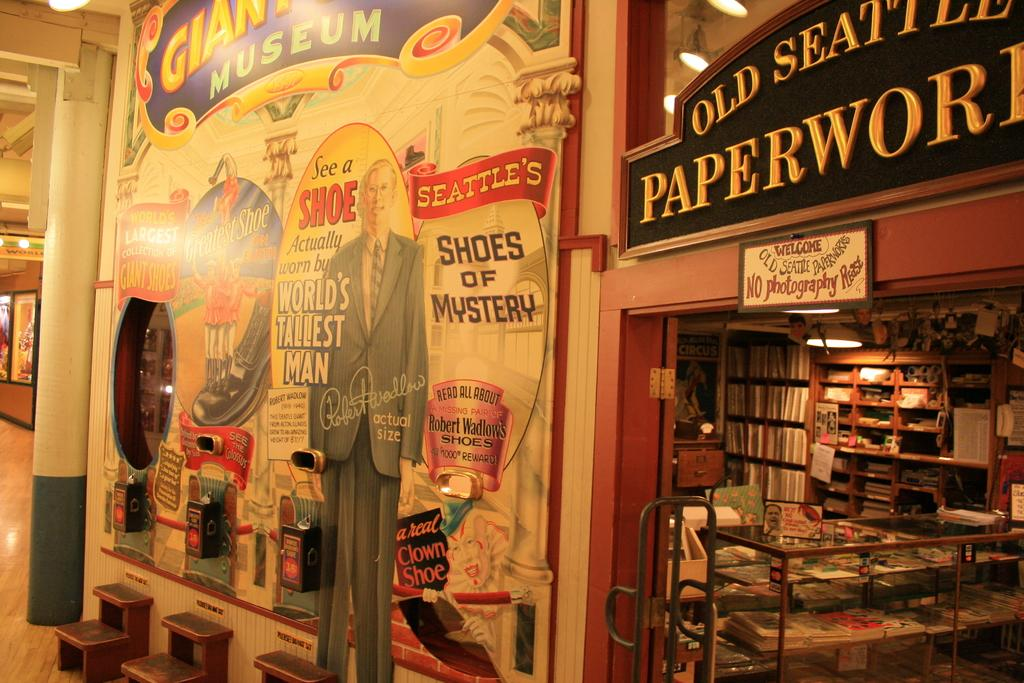<image>
Offer a succinct explanation of the picture presented. A museum in Seattle advertising historical shoes, including those worn by the world's tallest man. 